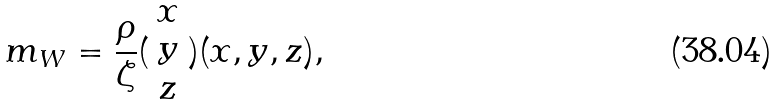<formula> <loc_0><loc_0><loc_500><loc_500>m _ { W } = \frac { \rho } { \zeta } ( \begin{array} { c } x \\ y \\ z \end{array} ) ( x , y , z ) ,</formula> 